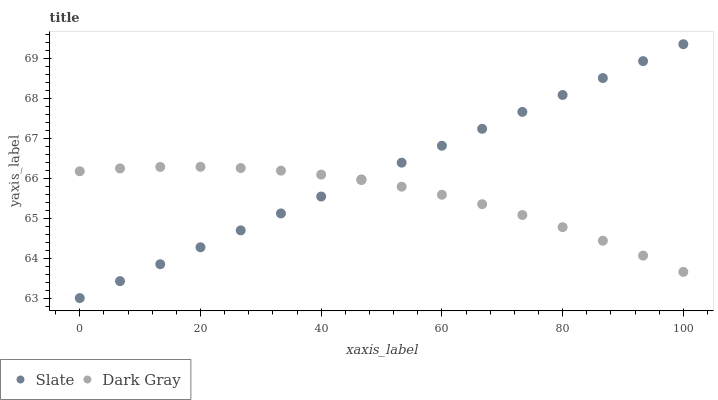Does Dark Gray have the minimum area under the curve?
Answer yes or no. Yes. Does Slate have the maximum area under the curve?
Answer yes or no. Yes. Does Slate have the minimum area under the curve?
Answer yes or no. No. Is Slate the smoothest?
Answer yes or no. Yes. Is Dark Gray the roughest?
Answer yes or no. Yes. Is Slate the roughest?
Answer yes or no. No. Does Slate have the lowest value?
Answer yes or no. Yes. Does Slate have the highest value?
Answer yes or no. Yes. Does Slate intersect Dark Gray?
Answer yes or no. Yes. Is Slate less than Dark Gray?
Answer yes or no. No. Is Slate greater than Dark Gray?
Answer yes or no. No. 